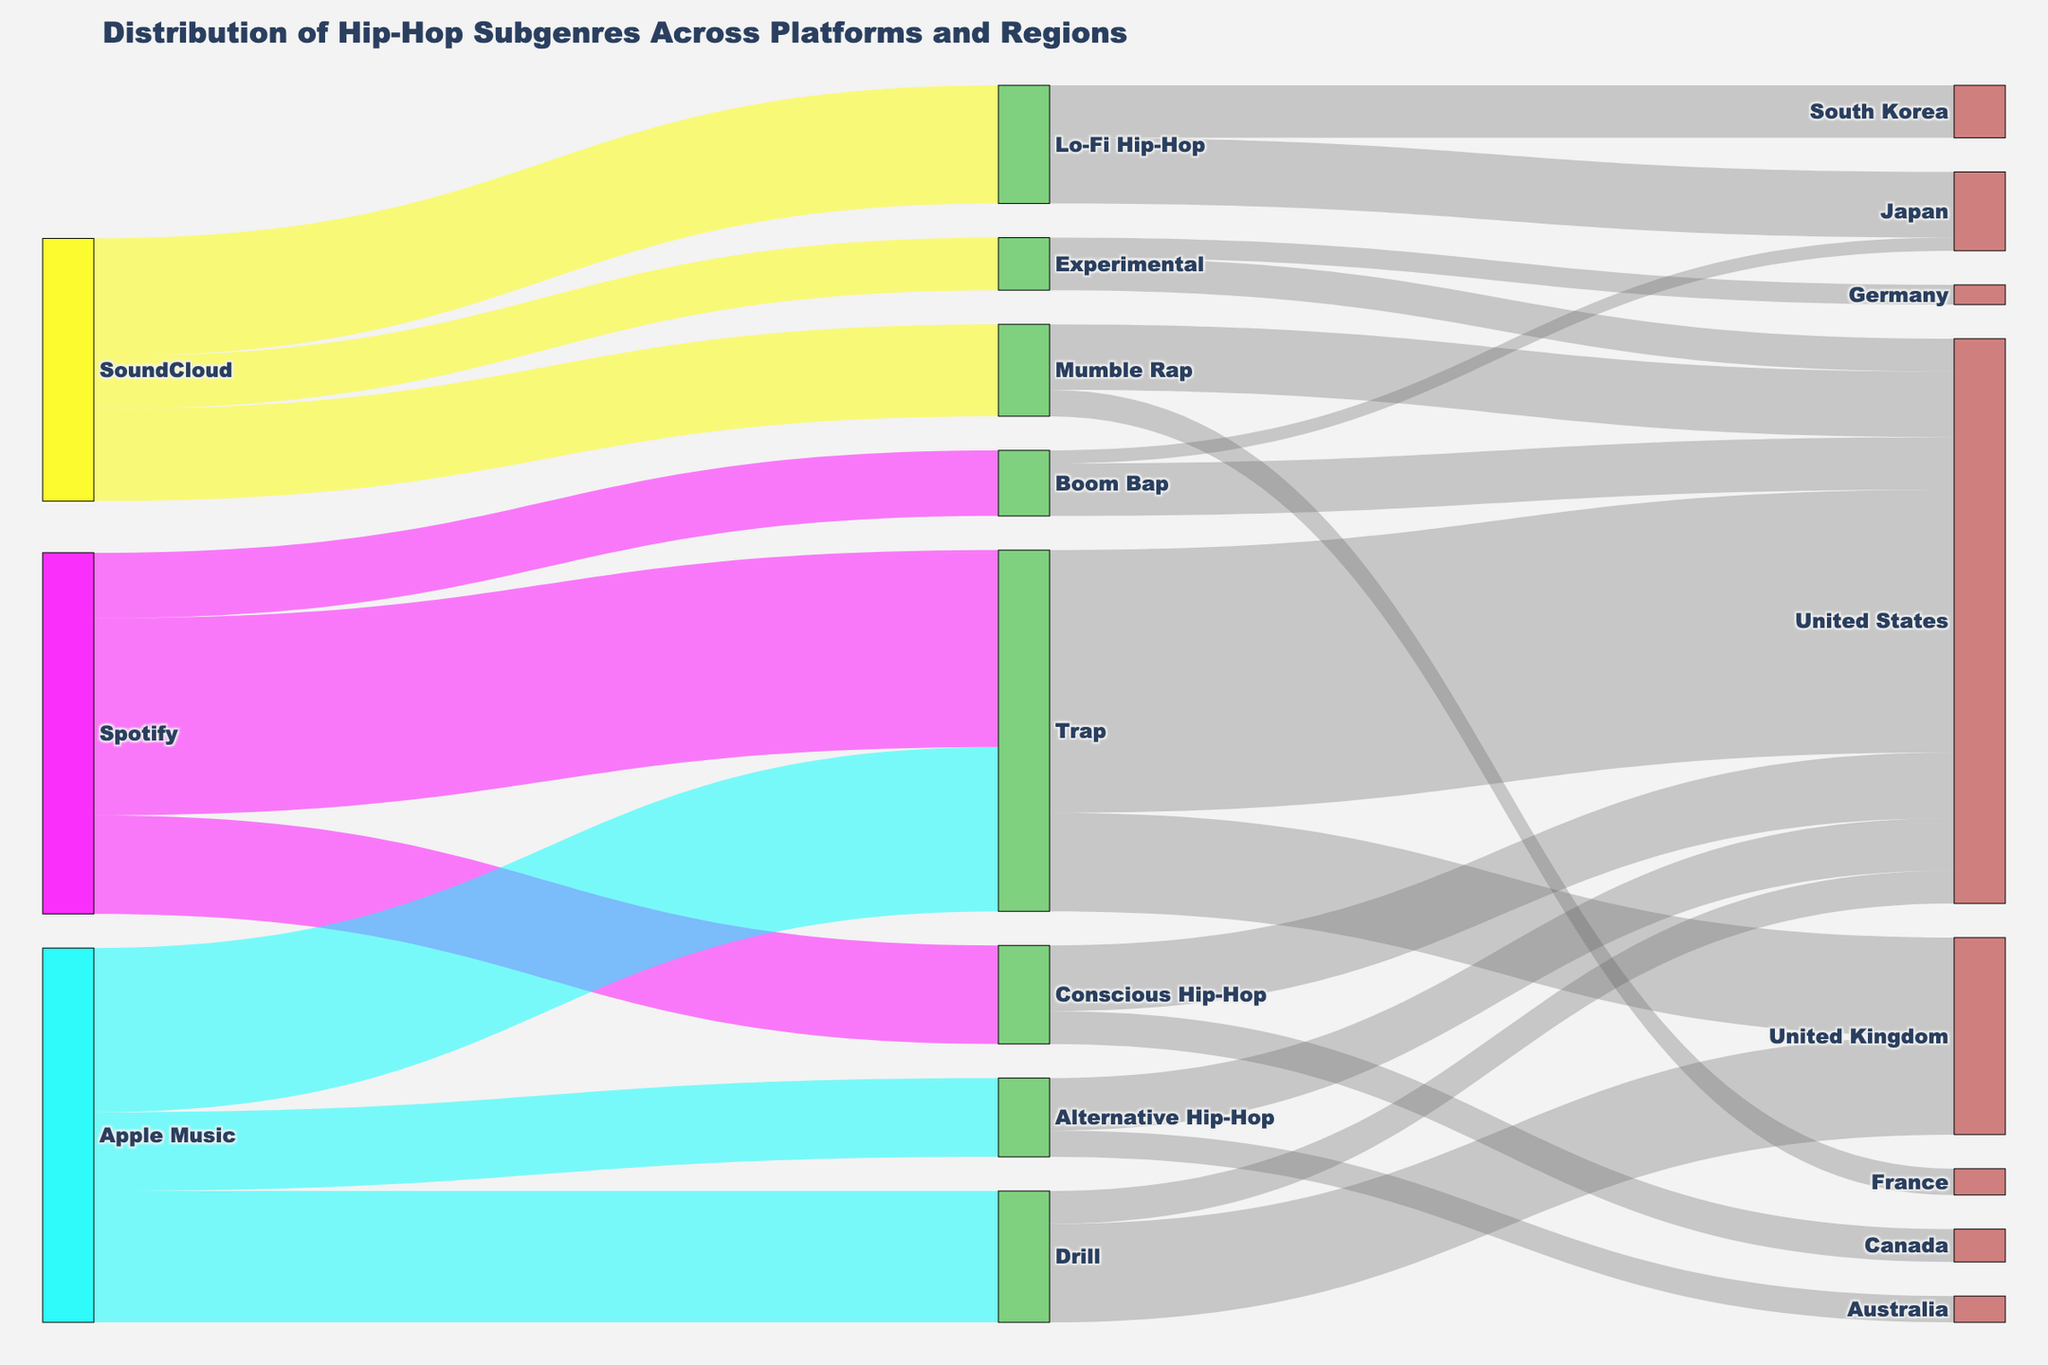Which subgenre is most popular on Spotify? Look at the nodes emanating from Spotify. Trap has the largest value emanating from Spotify, indicating it's the most popular.
Answer: Trap What is the total number of connections going out from Apple Music? Count the number of links originating from Apple Music. There are connections to Trap, Drill, and Alternative Hip-Hop, totaling 3.
Answer: 3 Which streaming platform has the least contribution to Lo-Fi Hip-Hop? Examine the links going into Lo-Fi Hip-Hop. Only SoundCloud contributes to this subgenre.
Answer: SoundCloud What is the combined value of Trap listeners in the United States and United Kingdom? Identify the links going from Trap to United States and United Kingdom and sum their values: 40 (US) + 15 (UK) = 55.
Answer: 55 Which geographical region has the lowest number of Boom Bap listeners? Look for the smallest value in the links emerging from Boom Bap. Japan has 2, which is the lowest.
Answer: Japan How does the number of Mumble Rap listeners in the United States compare to that in France? Compare the values in the connections from Mumble Rap to United States (10) and France (4). The number in the United States is higher.
Answer: United States What subgenres does Apple Music contribute to? Analyze the links originating from Apple Music. It contributes to Trap, Drill, and Alternative Hip-Hop.
Answer: Trap, Drill, Alternative Hip-Hop Which subgenre is exclusively contributed by SoundCloud? Investigate the connections to see which subgenre has links only from SoundCloud. Lo-Fi Hip-Hop, Experimental, and Mumble Rap are contributed exclusively by SoundCloud.
Answer: Lo-Fi Hip-Hop, Experimental, Mumble Rap 